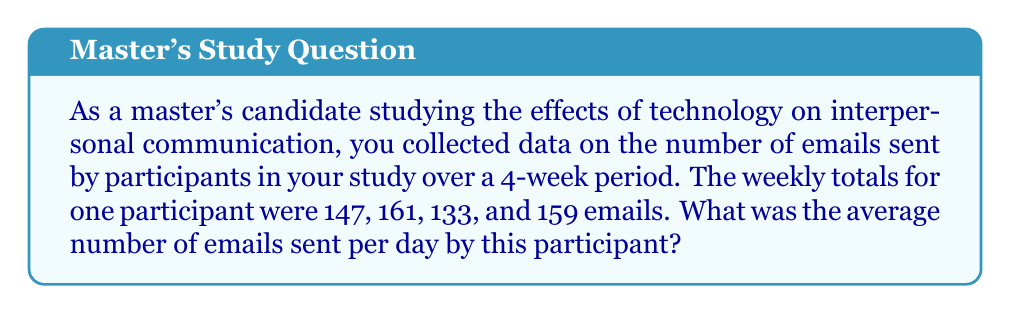Could you help me with this problem? To solve this problem, we'll follow these steps:

1. Calculate the total number of emails sent over the 4-week period:
   $$147 + 161 + 133 + 159 = 600$$ emails

2. Determine the number of days in 4 weeks:
   $$4 \text{ weeks} \times 7 \text{ days/week} = 28 \text{ days}$$

3. Calculate the average number of emails per day using the formula:
   $$\text{Average} = \frac{\text{Total emails}}{\text{Number of days}}$$

   $$\text{Average} = \frac{600}{28} = 21.428571...$$

4. Round the result to two decimal places:
   $$21.43 \text{ emails per day}$$

This average provides insight into the frequency of email communication for this participant, which is relevant to your study on the effects of technology on interpersonal communication.
Answer: $21.43$ emails per day 